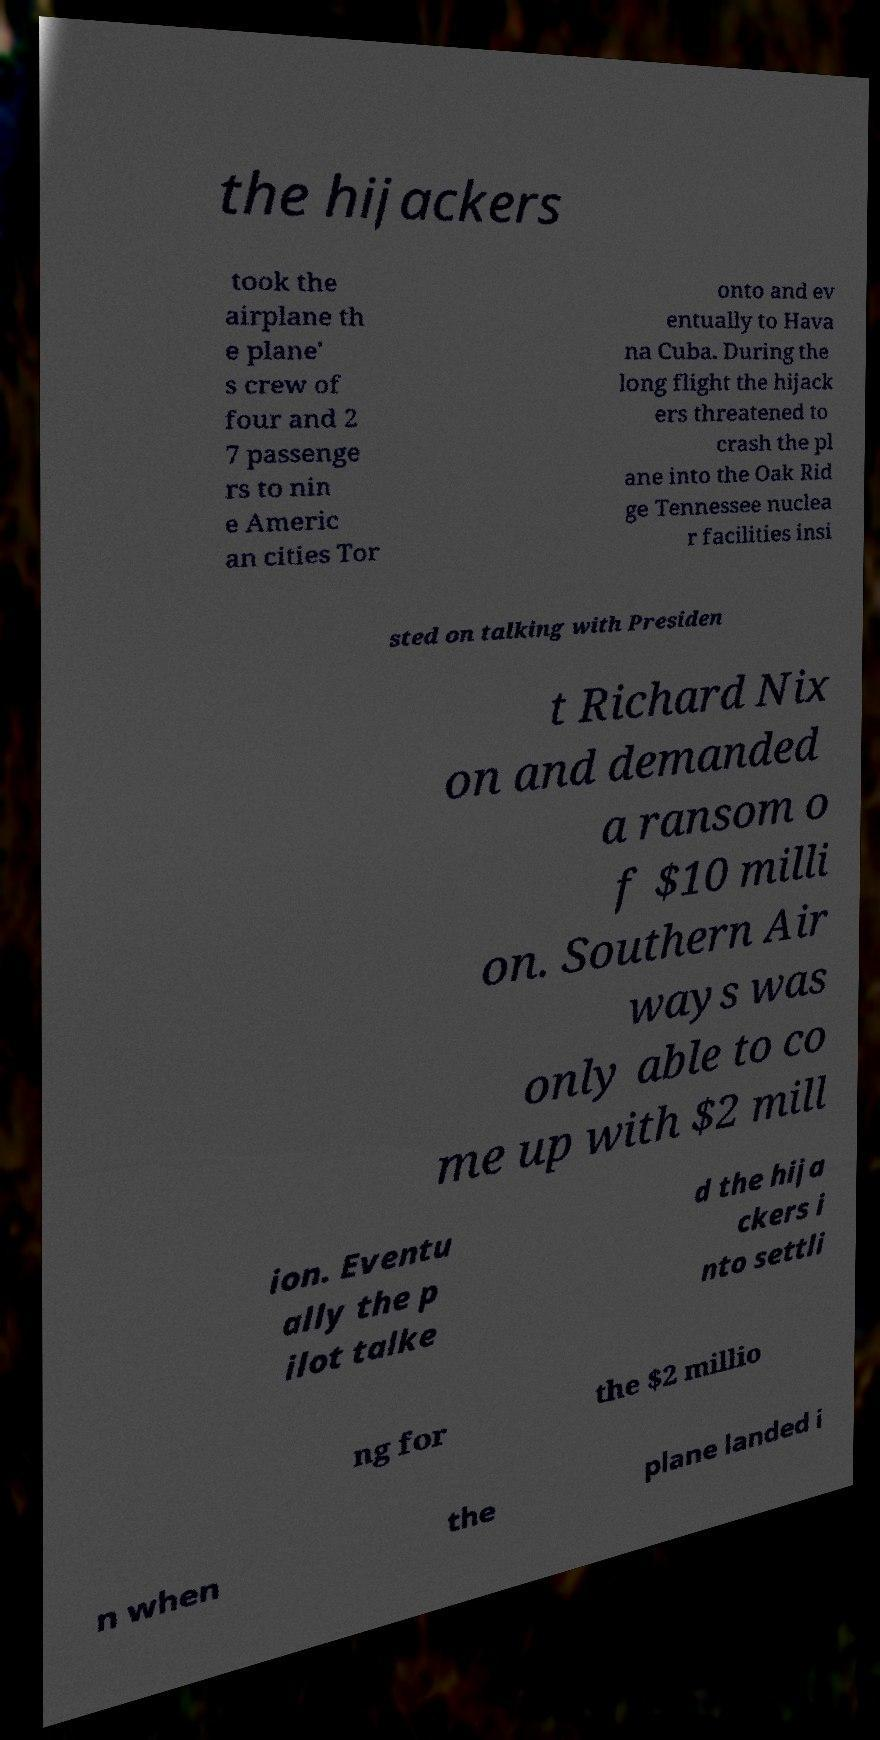Can you read and provide the text displayed in the image?This photo seems to have some interesting text. Can you extract and type it out for me? the hijackers took the airplane th e plane' s crew of four and 2 7 passenge rs to nin e Americ an cities Tor onto and ev entually to Hava na Cuba. During the long flight the hijack ers threatened to crash the pl ane into the Oak Rid ge Tennessee nuclea r facilities insi sted on talking with Presiden t Richard Nix on and demanded a ransom o f $10 milli on. Southern Air ways was only able to co me up with $2 mill ion. Eventu ally the p ilot talke d the hija ckers i nto settli ng for the $2 millio n when the plane landed i 